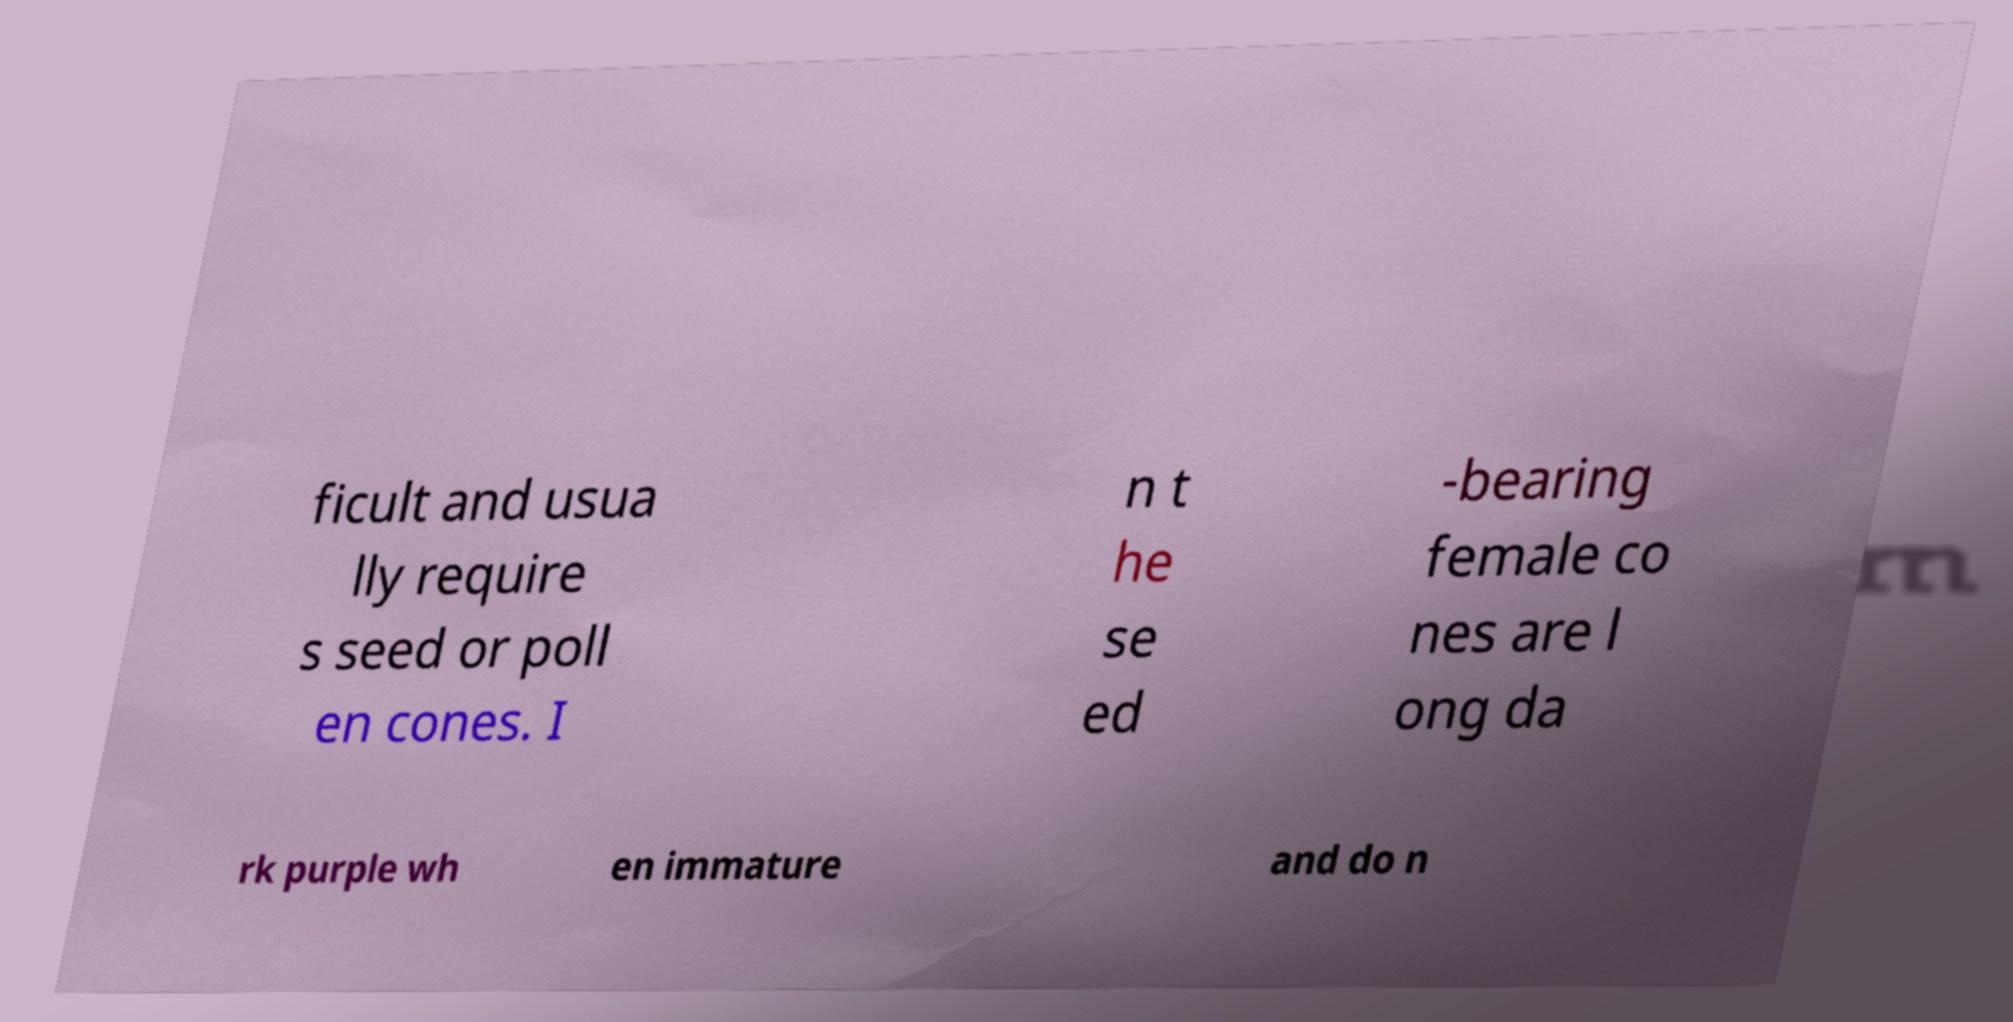There's text embedded in this image that I need extracted. Can you transcribe it verbatim? ficult and usua lly require s seed or poll en cones. I n t he se ed -bearing female co nes are l ong da rk purple wh en immature and do n 